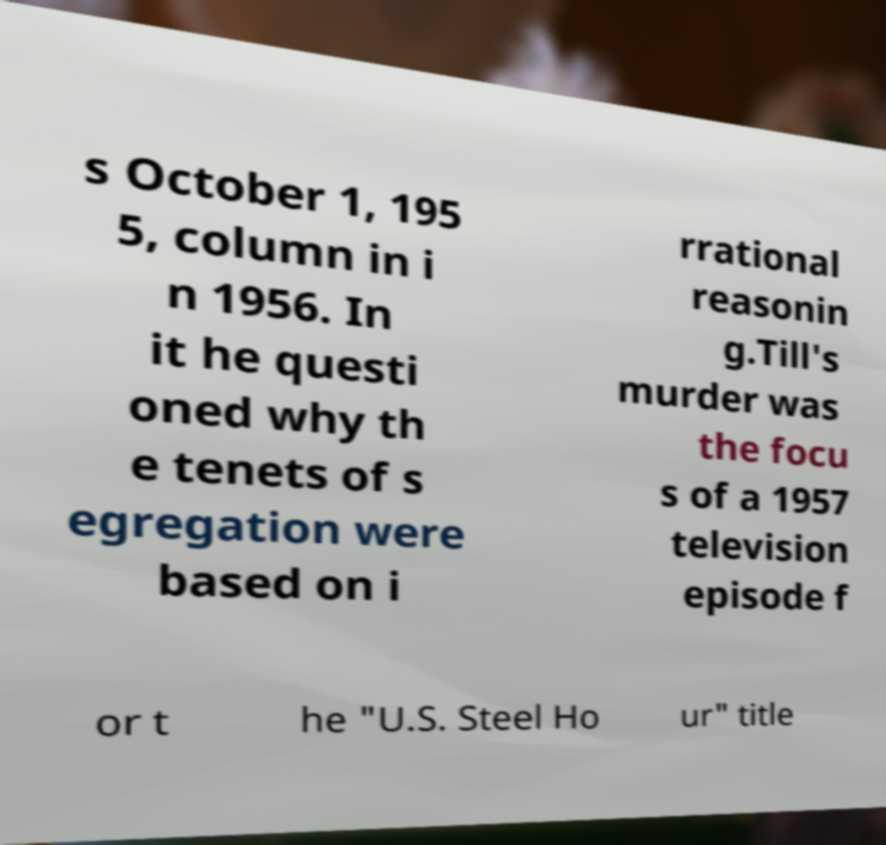What messages or text are displayed in this image? I need them in a readable, typed format. s October 1, 195 5, column in i n 1956. In it he questi oned why th e tenets of s egregation were based on i rrational reasonin g.Till's murder was the focu s of a 1957 television episode f or t he "U.S. Steel Ho ur" title 